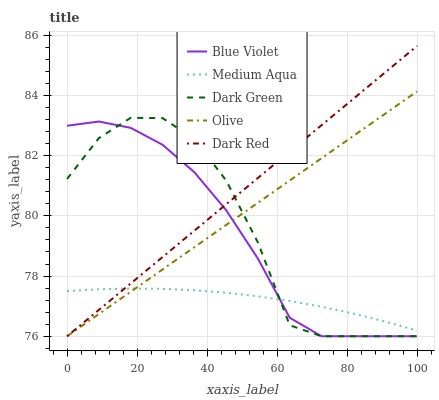Does Medium Aqua have the minimum area under the curve?
Answer yes or no. Yes. Does Dark Red have the maximum area under the curve?
Answer yes or no. Yes. Does Dark Red have the minimum area under the curve?
Answer yes or no. No. Does Medium Aqua have the maximum area under the curve?
Answer yes or no. No. Is Dark Red the smoothest?
Answer yes or no. Yes. Is Dark Green the roughest?
Answer yes or no. Yes. Is Medium Aqua the smoothest?
Answer yes or no. No. Is Medium Aqua the roughest?
Answer yes or no. No. Does Medium Aqua have the lowest value?
Answer yes or no. No. Does Medium Aqua have the highest value?
Answer yes or no. No. 